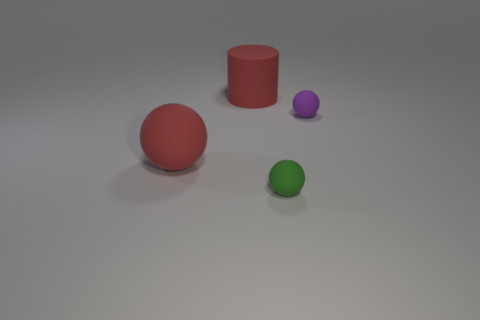Add 1 cyan rubber balls. How many objects exist? 5 Subtract all spheres. How many objects are left? 1 Subtract 1 red spheres. How many objects are left? 3 Subtract all small matte objects. Subtract all large red cylinders. How many objects are left? 1 Add 1 red matte things. How many red matte things are left? 3 Add 4 tiny blue cylinders. How many tiny blue cylinders exist? 4 